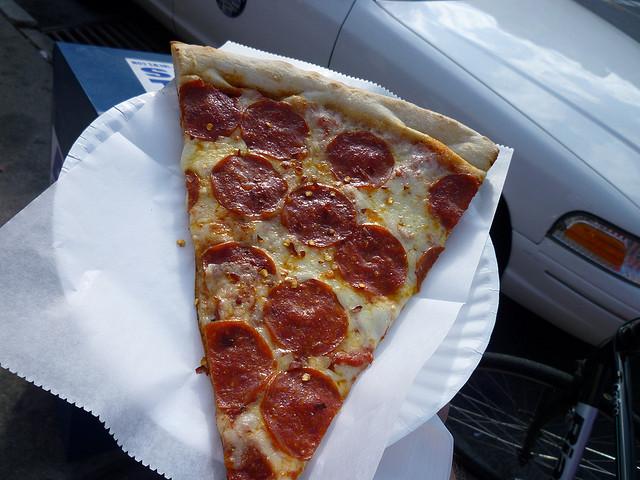What color is the car?
Concise answer only. White. What type of plate is the pizza on?
Give a very brief answer. Paper. Is a whole pizza?
Be succinct. No. Is this a vegetarian pizza?
Answer briefly. No. 